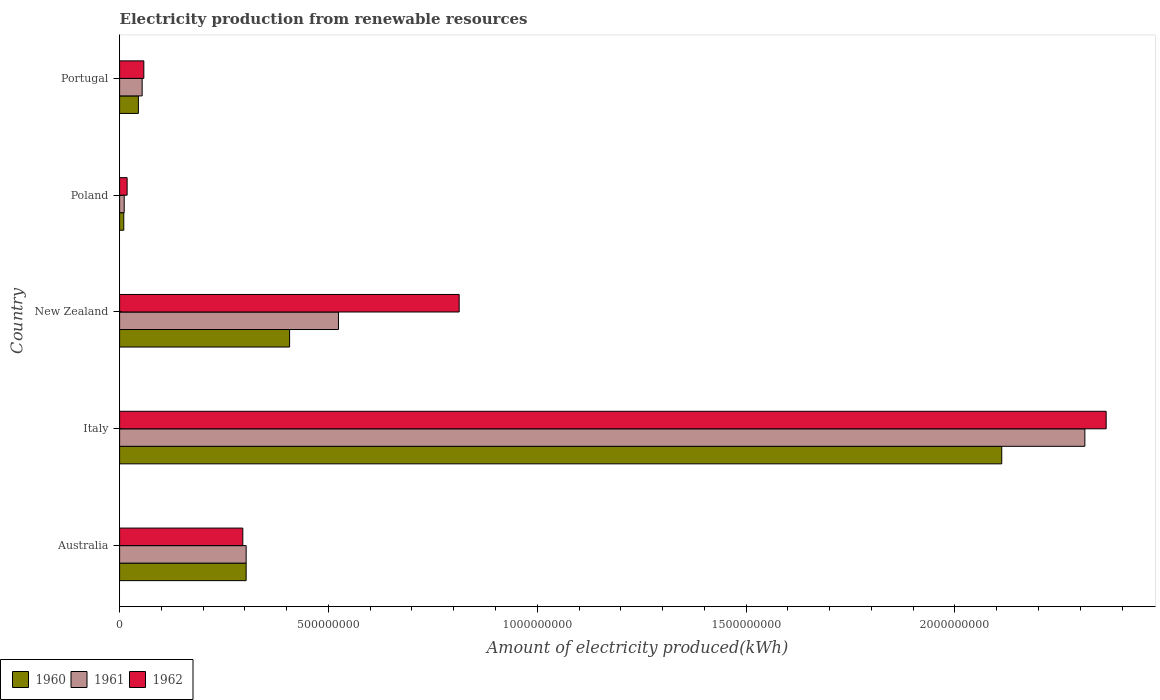Are the number of bars per tick equal to the number of legend labels?
Ensure brevity in your answer.  Yes. How many bars are there on the 3rd tick from the top?
Offer a very short reply. 3. How many bars are there on the 4th tick from the bottom?
Make the answer very short. 3. What is the amount of electricity produced in 1961 in Poland?
Keep it short and to the point. 1.10e+07. Across all countries, what is the maximum amount of electricity produced in 1961?
Make the answer very short. 2.31e+09. Across all countries, what is the minimum amount of electricity produced in 1961?
Offer a terse response. 1.10e+07. In which country was the amount of electricity produced in 1962 maximum?
Give a very brief answer. Italy. In which country was the amount of electricity produced in 1960 minimum?
Offer a terse response. Poland. What is the total amount of electricity produced in 1962 in the graph?
Provide a succinct answer. 3.55e+09. What is the difference between the amount of electricity produced in 1960 in Italy and that in Portugal?
Your answer should be compact. 2.07e+09. What is the difference between the amount of electricity produced in 1960 in Poland and the amount of electricity produced in 1962 in Italy?
Keep it short and to the point. -2.35e+09. What is the average amount of electricity produced in 1962 per country?
Offer a terse response. 7.09e+08. What is the difference between the amount of electricity produced in 1960 and amount of electricity produced in 1961 in Portugal?
Offer a very short reply. -9.00e+06. In how many countries, is the amount of electricity produced in 1962 greater than 1500000000 kWh?
Offer a very short reply. 1. What is the ratio of the amount of electricity produced in 1961 in Australia to that in Italy?
Your answer should be compact. 0.13. Is the amount of electricity produced in 1961 in New Zealand less than that in Poland?
Offer a terse response. No. Is the difference between the amount of electricity produced in 1960 in Italy and Portugal greater than the difference between the amount of electricity produced in 1961 in Italy and Portugal?
Give a very brief answer. No. What is the difference between the highest and the second highest amount of electricity produced in 1961?
Your response must be concise. 1.79e+09. What is the difference between the highest and the lowest amount of electricity produced in 1961?
Your response must be concise. 2.30e+09. Is the sum of the amount of electricity produced in 1960 in New Zealand and Poland greater than the maximum amount of electricity produced in 1961 across all countries?
Ensure brevity in your answer.  No. What is the difference between two consecutive major ticks on the X-axis?
Your answer should be compact. 5.00e+08. Are the values on the major ticks of X-axis written in scientific E-notation?
Your response must be concise. No. How many legend labels are there?
Your response must be concise. 3. What is the title of the graph?
Your response must be concise. Electricity production from renewable resources. What is the label or title of the X-axis?
Give a very brief answer. Amount of electricity produced(kWh). What is the label or title of the Y-axis?
Your answer should be compact. Country. What is the Amount of electricity produced(kWh) in 1960 in Australia?
Ensure brevity in your answer.  3.03e+08. What is the Amount of electricity produced(kWh) of 1961 in Australia?
Your answer should be compact. 3.03e+08. What is the Amount of electricity produced(kWh) of 1962 in Australia?
Provide a short and direct response. 2.95e+08. What is the Amount of electricity produced(kWh) in 1960 in Italy?
Ensure brevity in your answer.  2.11e+09. What is the Amount of electricity produced(kWh) in 1961 in Italy?
Your answer should be very brief. 2.31e+09. What is the Amount of electricity produced(kWh) of 1962 in Italy?
Give a very brief answer. 2.36e+09. What is the Amount of electricity produced(kWh) of 1960 in New Zealand?
Provide a succinct answer. 4.07e+08. What is the Amount of electricity produced(kWh) of 1961 in New Zealand?
Give a very brief answer. 5.24e+08. What is the Amount of electricity produced(kWh) of 1962 in New Zealand?
Make the answer very short. 8.13e+08. What is the Amount of electricity produced(kWh) in 1960 in Poland?
Offer a terse response. 1.00e+07. What is the Amount of electricity produced(kWh) in 1961 in Poland?
Your answer should be compact. 1.10e+07. What is the Amount of electricity produced(kWh) in 1962 in Poland?
Your response must be concise. 1.80e+07. What is the Amount of electricity produced(kWh) of 1960 in Portugal?
Provide a short and direct response. 4.50e+07. What is the Amount of electricity produced(kWh) in 1961 in Portugal?
Make the answer very short. 5.40e+07. What is the Amount of electricity produced(kWh) in 1962 in Portugal?
Give a very brief answer. 5.80e+07. Across all countries, what is the maximum Amount of electricity produced(kWh) of 1960?
Your answer should be very brief. 2.11e+09. Across all countries, what is the maximum Amount of electricity produced(kWh) of 1961?
Your answer should be very brief. 2.31e+09. Across all countries, what is the maximum Amount of electricity produced(kWh) in 1962?
Offer a very short reply. 2.36e+09. Across all countries, what is the minimum Amount of electricity produced(kWh) in 1961?
Your answer should be very brief. 1.10e+07. Across all countries, what is the minimum Amount of electricity produced(kWh) of 1962?
Provide a short and direct response. 1.80e+07. What is the total Amount of electricity produced(kWh) of 1960 in the graph?
Make the answer very short. 2.88e+09. What is the total Amount of electricity produced(kWh) of 1961 in the graph?
Your answer should be compact. 3.20e+09. What is the total Amount of electricity produced(kWh) in 1962 in the graph?
Offer a terse response. 3.55e+09. What is the difference between the Amount of electricity produced(kWh) in 1960 in Australia and that in Italy?
Provide a succinct answer. -1.81e+09. What is the difference between the Amount of electricity produced(kWh) in 1961 in Australia and that in Italy?
Provide a succinct answer. -2.01e+09. What is the difference between the Amount of electricity produced(kWh) in 1962 in Australia and that in Italy?
Offer a very short reply. -2.07e+09. What is the difference between the Amount of electricity produced(kWh) of 1960 in Australia and that in New Zealand?
Offer a very short reply. -1.04e+08. What is the difference between the Amount of electricity produced(kWh) of 1961 in Australia and that in New Zealand?
Offer a terse response. -2.21e+08. What is the difference between the Amount of electricity produced(kWh) of 1962 in Australia and that in New Zealand?
Your answer should be compact. -5.18e+08. What is the difference between the Amount of electricity produced(kWh) of 1960 in Australia and that in Poland?
Offer a very short reply. 2.93e+08. What is the difference between the Amount of electricity produced(kWh) of 1961 in Australia and that in Poland?
Offer a terse response. 2.92e+08. What is the difference between the Amount of electricity produced(kWh) in 1962 in Australia and that in Poland?
Give a very brief answer. 2.77e+08. What is the difference between the Amount of electricity produced(kWh) in 1960 in Australia and that in Portugal?
Keep it short and to the point. 2.58e+08. What is the difference between the Amount of electricity produced(kWh) in 1961 in Australia and that in Portugal?
Keep it short and to the point. 2.49e+08. What is the difference between the Amount of electricity produced(kWh) in 1962 in Australia and that in Portugal?
Provide a succinct answer. 2.37e+08. What is the difference between the Amount of electricity produced(kWh) of 1960 in Italy and that in New Zealand?
Offer a terse response. 1.70e+09. What is the difference between the Amount of electricity produced(kWh) in 1961 in Italy and that in New Zealand?
Offer a very short reply. 1.79e+09. What is the difference between the Amount of electricity produced(kWh) of 1962 in Italy and that in New Zealand?
Provide a succinct answer. 1.55e+09. What is the difference between the Amount of electricity produced(kWh) in 1960 in Italy and that in Poland?
Provide a short and direct response. 2.10e+09. What is the difference between the Amount of electricity produced(kWh) of 1961 in Italy and that in Poland?
Provide a succinct answer. 2.30e+09. What is the difference between the Amount of electricity produced(kWh) in 1962 in Italy and that in Poland?
Provide a succinct answer. 2.34e+09. What is the difference between the Amount of electricity produced(kWh) in 1960 in Italy and that in Portugal?
Provide a succinct answer. 2.07e+09. What is the difference between the Amount of electricity produced(kWh) of 1961 in Italy and that in Portugal?
Your answer should be very brief. 2.26e+09. What is the difference between the Amount of electricity produced(kWh) of 1962 in Italy and that in Portugal?
Give a very brief answer. 2.30e+09. What is the difference between the Amount of electricity produced(kWh) in 1960 in New Zealand and that in Poland?
Offer a very short reply. 3.97e+08. What is the difference between the Amount of electricity produced(kWh) in 1961 in New Zealand and that in Poland?
Give a very brief answer. 5.13e+08. What is the difference between the Amount of electricity produced(kWh) in 1962 in New Zealand and that in Poland?
Offer a terse response. 7.95e+08. What is the difference between the Amount of electricity produced(kWh) of 1960 in New Zealand and that in Portugal?
Make the answer very short. 3.62e+08. What is the difference between the Amount of electricity produced(kWh) of 1961 in New Zealand and that in Portugal?
Your answer should be very brief. 4.70e+08. What is the difference between the Amount of electricity produced(kWh) of 1962 in New Zealand and that in Portugal?
Your response must be concise. 7.55e+08. What is the difference between the Amount of electricity produced(kWh) in 1960 in Poland and that in Portugal?
Give a very brief answer. -3.50e+07. What is the difference between the Amount of electricity produced(kWh) in 1961 in Poland and that in Portugal?
Offer a terse response. -4.30e+07. What is the difference between the Amount of electricity produced(kWh) in 1962 in Poland and that in Portugal?
Make the answer very short. -4.00e+07. What is the difference between the Amount of electricity produced(kWh) in 1960 in Australia and the Amount of electricity produced(kWh) in 1961 in Italy?
Ensure brevity in your answer.  -2.01e+09. What is the difference between the Amount of electricity produced(kWh) in 1960 in Australia and the Amount of electricity produced(kWh) in 1962 in Italy?
Your answer should be compact. -2.06e+09. What is the difference between the Amount of electricity produced(kWh) of 1961 in Australia and the Amount of electricity produced(kWh) of 1962 in Italy?
Provide a short and direct response. -2.06e+09. What is the difference between the Amount of electricity produced(kWh) in 1960 in Australia and the Amount of electricity produced(kWh) in 1961 in New Zealand?
Provide a short and direct response. -2.21e+08. What is the difference between the Amount of electricity produced(kWh) of 1960 in Australia and the Amount of electricity produced(kWh) of 1962 in New Zealand?
Make the answer very short. -5.10e+08. What is the difference between the Amount of electricity produced(kWh) of 1961 in Australia and the Amount of electricity produced(kWh) of 1962 in New Zealand?
Give a very brief answer. -5.10e+08. What is the difference between the Amount of electricity produced(kWh) in 1960 in Australia and the Amount of electricity produced(kWh) in 1961 in Poland?
Offer a terse response. 2.92e+08. What is the difference between the Amount of electricity produced(kWh) of 1960 in Australia and the Amount of electricity produced(kWh) of 1962 in Poland?
Your answer should be compact. 2.85e+08. What is the difference between the Amount of electricity produced(kWh) in 1961 in Australia and the Amount of electricity produced(kWh) in 1962 in Poland?
Provide a short and direct response. 2.85e+08. What is the difference between the Amount of electricity produced(kWh) in 1960 in Australia and the Amount of electricity produced(kWh) in 1961 in Portugal?
Give a very brief answer. 2.49e+08. What is the difference between the Amount of electricity produced(kWh) in 1960 in Australia and the Amount of electricity produced(kWh) in 1962 in Portugal?
Give a very brief answer. 2.45e+08. What is the difference between the Amount of electricity produced(kWh) of 1961 in Australia and the Amount of electricity produced(kWh) of 1962 in Portugal?
Keep it short and to the point. 2.45e+08. What is the difference between the Amount of electricity produced(kWh) in 1960 in Italy and the Amount of electricity produced(kWh) in 1961 in New Zealand?
Offer a very short reply. 1.59e+09. What is the difference between the Amount of electricity produced(kWh) in 1960 in Italy and the Amount of electricity produced(kWh) in 1962 in New Zealand?
Your answer should be compact. 1.30e+09. What is the difference between the Amount of electricity produced(kWh) in 1961 in Italy and the Amount of electricity produced(kWh) in 1962 in New Zealand?
Keep it short and to the point. 1.50e+09. What is the difference between the Amount of electricity produced(kWh) of 1960 in Italy and the Amount of electricity produced(kWh) of 1961 in Poland?
Offer a terse response. 2.10e+09. What is the difference between the Amount of electricity produced(kWh) of 1960 in Italy and the Amount of electricity produced(kWh) of 1962 in Poland?
Offer a terse response. 2.09e+09. What is the difference between the Amount of electricity produced(kWh) of 1961 in Italy and the Amount of electricity produced(kWh) of 1962 in Poland?
Provide a short and direct response. 2.29e+09. What is the difference between the Amount of electricity produced(kWh) of 1960 in Italy and the Amount of electricity produced(kWh) of 1961 in Portugal?
Provide a short and direct response. 2.06e+09. What is the difference between the Amount of electricity produced(kWh) of 1960 in Italy and the Amount of electricity produced(kWh) of 1962 in Portugal?
Offer a very short reply. 2.05e+09. What is the difference between the Amount of electricity produced(kWh) of 1961 in Italy and the Amount of electricity produced(kWh) of 1962 in Portugal?
Your response must be concise. 2.25e+09. What is the difference between the Amount of electricity produced(kWh) in 1960 in New Zealand and the Amount of electricity produced(kWh) in 1961 in Poland?
Provide a short and direct response. 3.96e+08. What is the difference between the Amount of electricity produced(kWh) in 1960 in New Zealand and the Amount of electricity produced(kWh) in 1962 in Poland?
Offer a very short reply. 3.89e+08. What is the difference between the Amount of electricity produced(kWh) in 1961 in New Zealand and the Amount of electricity produced(kWh) in 1962 in Poland?
Make the answer very short. 5.06e+08. What is the difference between the Amount of electricity produced(kWh) of 1960 in New Zealand and the Amount of electricity produced(kWh) of 1961 in Portugal?
Offer a very short reply. 3.53e+08. What is the difference between the Amount of electricity produced(kWh) in 1960 in New Zealand and the Amount of electricity produced(kWh) in 1962 in Portugal?
Keep it short and to the point. 3.49e+08. What is the difference between the Amount of electricity produced(kWh) of 1961 in New Zealand and the Amount of electricity produced(kWh) of 1962 in Portugal?
Ensure brevity in your answer.  4.66e+08. What is the difference between the Amount of electricity produced(kWh) of 1960 in Poland and the Amount of electricity produced(kWh) of 1961 in Portugal?
Ensure brevity in your answer.  -4.40e+07. What is the difference between the Amount of electricity produced(kWh) in 1960 in Poland and the Amount of electricity produced(kWh) in 1962 in Portugal?
Offer a very short reply. -4.80e+07. What is the difference between the Amount of electricity produced(kWh) of 1961 in Poland and the Amount of electricity produced(kWh) of 1962 in Portugal?
Offer a terse response. -4.70e+07. What is the average Amount of electricity produced(kWh) in 1960 per country?
Offer a very short reply. 5.75e+08. What is the average Amount of electricity produced(kWh) in 1961 per country?
Ensure brevity in your answer.  6.41e+08. What is the average Amount of electricity produced(kWh) in 1962 per country?
Provide a short and direct response. 7.09e+08. What is the difference between the Amount of electricity produced(kWh) of 1960 and Amount of electricity produced(kWh) of 1961 in Australia?
Your answer should be compact. 0. What is the difference between the Amount of electricity produced(kWh) in 1961 and Amount of electricity produced(kWh) in 1962 in Australia?
Keep it short and to the point. 8.00e+06. What is the difference between the Amount of electricity produced(kWh) in 1960 and Amount of electricity produced(kWh) in 1961 in Italy?
Offer a very short reply. -1.99e+08. What is the difference between the Amount of electricity produced(kWh) in 1960 and Amount of electricity produced(kWh) in 1962 in Italy?
Keep it short and to the point. -2.50e+08. What is the difference between the Amount of electricity produced(kWh) in 1961 and Amount of electricity produced(kWh) in 1962 in Italy?
Make the answer very short. -5.10e+07. What is the difference between the Amount of electricity produced(kWh) of 1960 and Amount of electricity produced(kWh) of 1961 in New Zealand?
Provide a short and direct response. -1.17e+08. What is the difference between the Amount of electricity produced(kWh) of 1960 and Amount of electricity produced(kWh) of 1962 in New Zealand?
Give a very brief answer. -4.06e+08. What is the difference between the Amount of electricity produced(kWh) in 1961 and Amount of electricity produced(kWh) in 1962 in New Zealand?
Offer a very short reply. -2.89e+08. What is the difference between the Amount of electricity produced(kWh) in 1960 and Amount of electricity produced(kWh) in 1962 in Poland?
Keep it short and to the point. -8.00e+06. What is the difference between the Amount of electricity produced(kWh) in 1961 and Amount of electricity produced(kWh) in 1962 in Poland?
Provide a succinct answer. -7.00e+06. What is the difference between the Amount of electricity produced(kWh) in 1960 and Amount of electricity produced(kWh) in 1961 in Portugal?
Provide a short and direct response. -9.00e+06. What is the difference between the Amount of electricity produced(kWh) in 1960 and Amount of electricity produced(kWh) in 1962 in Portugal?
Your response must be concise. -1.30e+07. What is the ratio of the Amount of electricity produced(kWh) of 1960 in Australia to that in Italy?
Your answer should be very brief. 0.14. What is the ratio of the Amount of electricity produced(kWh) in 1961 in Australia to that in Italy?
Give a very brief answer. 0.13. What is the ratio of the Amount of electricity produced(kWh) of 1962 in Australia to that in Italy?
Keep it short and to the point. 0.12. What is the ratio of the Amount of electricity produced(kWh) of 1960 in Australia to that in New Zealand?
Your response must be concise. 0.74. What is the ratio of the Amount of electricity produced(kWh) in 1961 in Australia to that in New Zealand?
Your answer should be very brief. 0.58. What is the ratio of the Amount of electricity produced(kWh) in 1962 in Australia to that in New Zealand?
Give a very brief answer. 0.36. What is the ratio of the Amount of electricity produced(kWh) of 1960 in Australia to that in Poland?
Your answer should be very brief. 30.3. What is the ratio of the Amount of electricity produced(kWh) in 1961 in Australia to that in Poland?
Give a very brief answer. 27.55. What is the ratio of the Amount of electricity produced(kWh) in 1962 in Australia to that in Poland?
Make the answer very short. 16.39. What is the ratio of the Amount of electricity produced(kWh) in 1960 in Australia to that in Portugal?
Keep it short and to the point. 6.73. What is the ratio of the Amount of electricity produced(kWh) of 1961 in Australia to that in Portugal?
Your response must be concise. 5.61. What is the ratio of the Amount of electricity produced(kWh) of 1962 in Australia to that in Portugal?
Keep it short and to the point. 5.09. What is the ratio of the Amount of electricity produced(kWh) of 1960 in Italy to that in New Zealand?
Provide a succinct answer. 5.19. What is the ratio of the Amount of electricity produced(kWh) of 1961 in Italy to that in New Zealand?
Offer a terse response. 4.41. What is the ratio of the Amount of electricity produced(kWh) in 1962 in Italy to that in New Zealand?
Keep it short and to the point. 2.91. What is the ratio of the Amount of electricity produced(kWh) in 1960 in Italy to that in Poland?
Your response must be concise. 211.2. What is the ratio of the Amount of electricity produced(kWh) of 1961 in Italy to that in Poland?
Provide a short and direct response. 210.09. What is the ratio of the Amount of electricity produced(kWh) in 1962 in Italy to that in Poland?
Offer a very short reply. 131.22. What is the ratio of the Amount of electricity produced(kWh) in 1960 in Italy to that in Portugal?
Your answer should be very brief. 46.93. What is the ratio of the Amount of electricity produced(kWh) in 1961 in Italy to that in Portugal?
Your answer should be very brief. 42.8. What is the ratio of the Amount of electricity produced(kWh) in 1962 in Italy to that in Portugal?
Provide a short and direct response. 40.72. What is the ratio of the Amount of electricity produced(kWh) in 1960 in New Zealand to that in Poland?
Provide a short and direct response. 40.7. What is the ratio of the Amount of electricity produced(kWh) of 1961 in New Zealand to that in Poland?
Your response must be concise. 47.64. What is the ratio of the Amount of electricity produced(kWh) of 1962 in New Zealand to that in Poland?
Keep it short and to the point. 45.17. What is the ratio of the Amount of electricity produced(kWh) in 1960 in New Zealand to that in Portugal?
Provide a short and direct response. 9.04. What is the ratio of the Amount of electricity produced(kWh) in 1961 in New Zealand to that in Portugal?
Provide a short and direct response. 9.7. What is the ratio of the Amount of electricity produced(kWh) of 1962 in New Zealand to that in Portugal?
Ensure brevity in your answer.  14.02. What is the ratio of the Amount of electricity produced(kWh) in 1960 in Poland to that in Portugal?
Make the answer very short. 0.22. What is the ratio of the Amount of electricity produced(kWh) in 1961 in Poland to that in Portugal?
Offer a terse response. 0.2. What is the ratio of the Amount of electricity produced(kWh) of 1962 in Poland to that in Portugal?
Make the answer very short. 0.31. What is the difference between the highest and the second highest Amount of electricity produced(kWh) of 1960?
Your response must be concise. 1.70e+09. What is the difference between the highest and the second highest Amount of electricity produced(kWh) of 1961?
Give a very brief answer. 1.79e+09. What is the difference between the highest and the second highest Amount of electricity produced(kWh) of 1962?
Make the answer very short. 1.55e+09. What is the difference between the highest and the lowest Amount of electricity produced(kWh) in 1960?
Offer a terse response. 2.10e+09. What is the difference between the highest and the lowest Amount of electricity produced(kWh) of 1961?
Provide a succinct answer. 2.30e+09. What is the difference between the highest and the lowest Amount of electricity produced(kWh) in 1962?
Offer a terse response. 2.34e+09. 